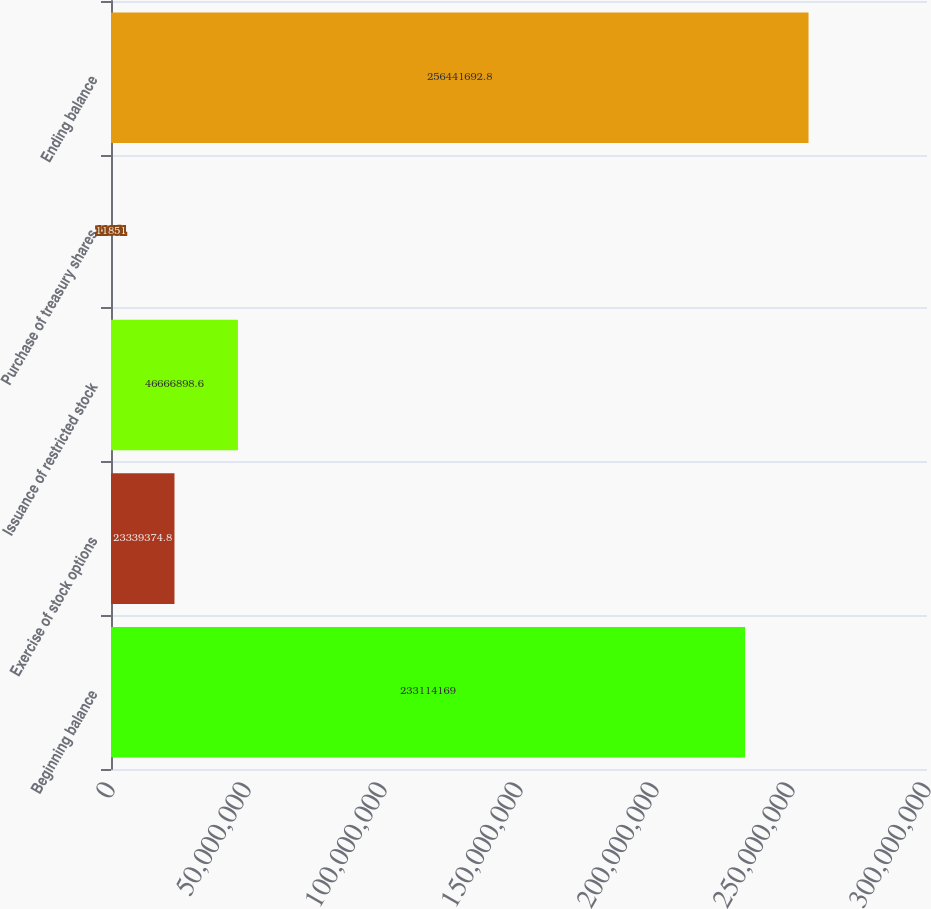Convert chart to OTSL. <chart><loc_0><loc_0><loc_500><loc_500><bar_chart><fcel>Beginning balance<fcel>Exercise of stock options<fcel>Issuance of restricted stock<fcel>Purchase of treasury shares<fcel>Ending balance<nl><fcel>2.33114e+08<fcel>2.33394e+07<fcel>4.66669e+07<fcel>11851<fcel>2.56442e+08<nl></chart> 